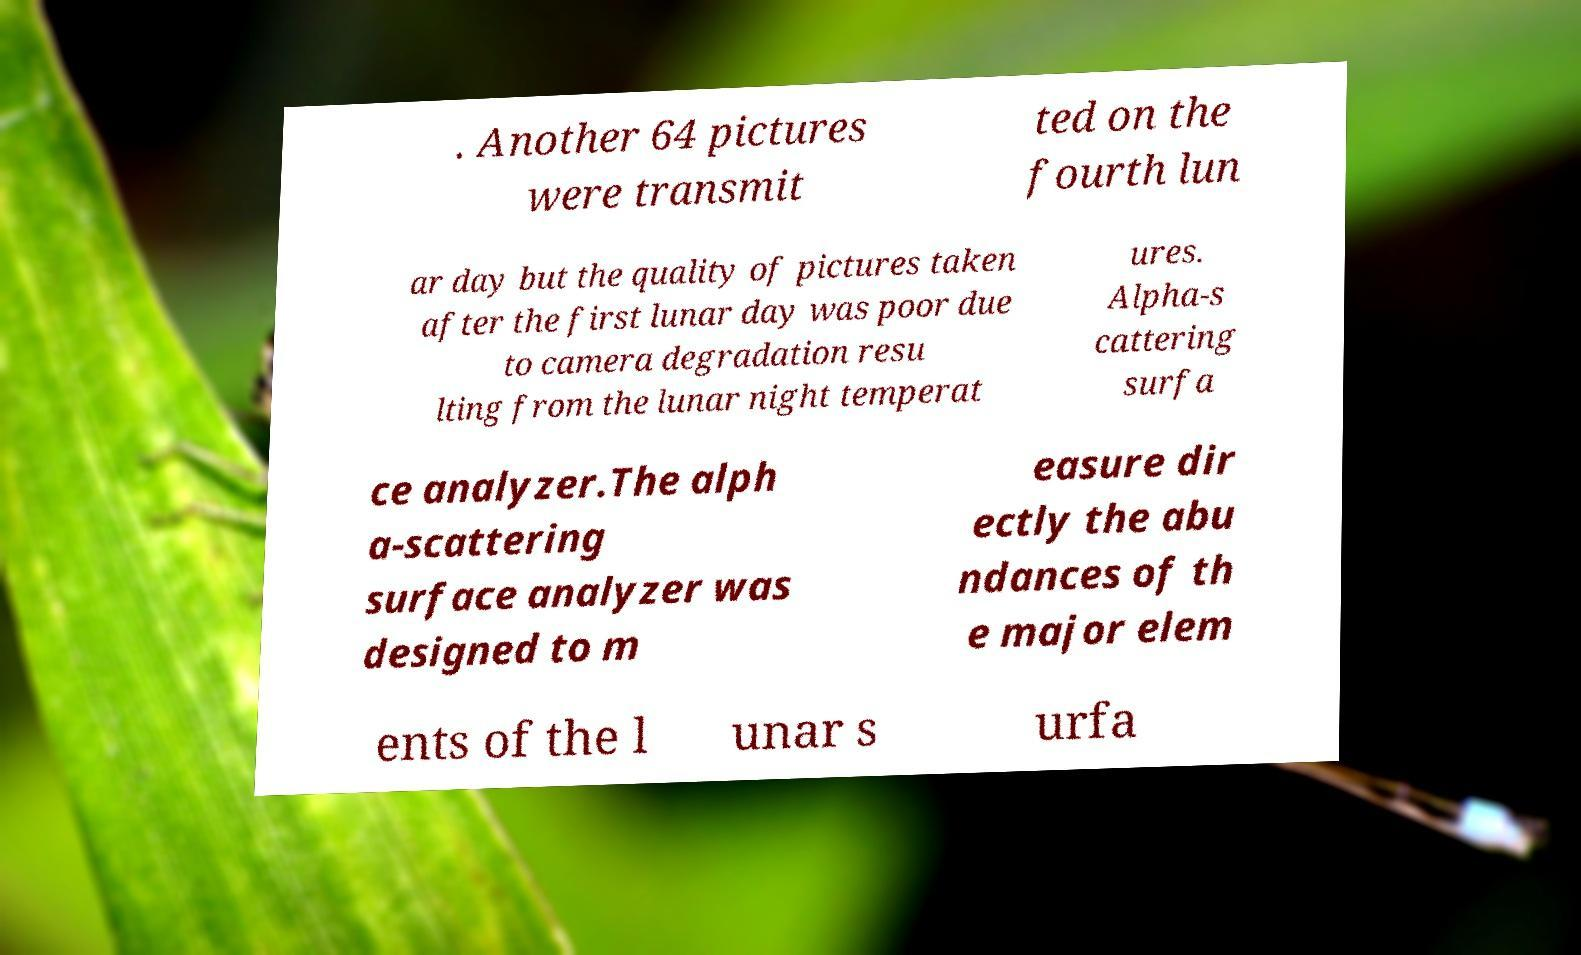For documentation purposes, I need the text within this image transcribed. Could you provide that? . Another 64 pictures were transmit ted on the fourth lun ar day but the quality of pictures taken after the first lunar day was poor due to camera degradation resu lting from the lunar night temperat ures. Alpha-s cattering surfa ce analyzer.The alph a-scattering surface analyzer was designed to m easure dir ectly the abu ndances of th e major elem ents of the l unar s urfa 